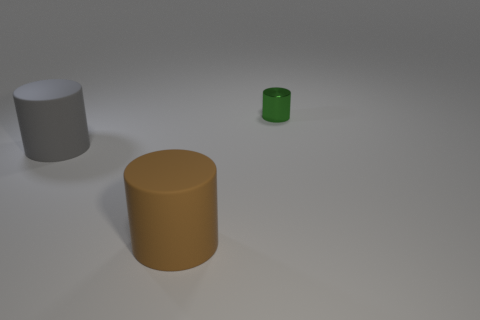Subtract all small shiny cylinders. How many cylinders are left? 2 Subtract all brown cylinders. How many cylinders are left? 2 Add 2 gray rubber cylinders. How many objects exist? 5 Subtract 1 brown cylinders. How many objects are left? 2 Subtract 3 cylinders. How many cylinders are left? 0 Subtract all gray cylinders. Subtract all purple blocks. How many cylinders are left? 2 Subtract all blue blocks. How many cyan cylinders are left? 0 Subtract all big brown things. Subtract all big brown things. How many objects are left? 1 Add 3 shiny things. How many shiny things are left? 4 Add 2 big brown cylinders. How many big brown cylinders exist? 3 